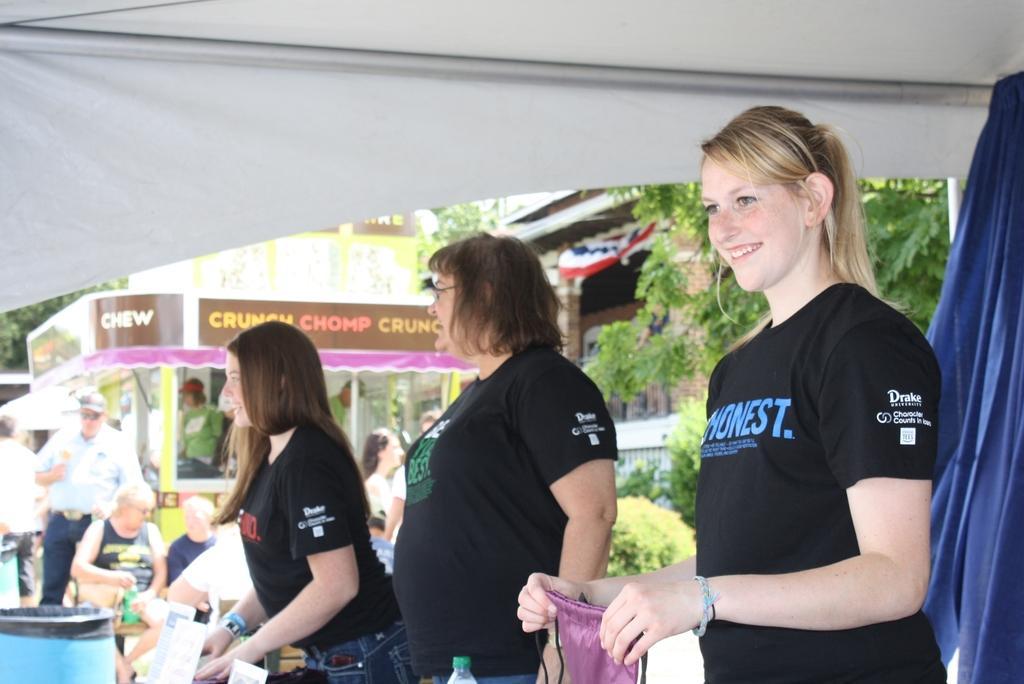Please provide a concise description of this image. In this image I can see a crowd on the road, curtain, tent, vehicles, trees and a building. This image is taken may be during a day. 